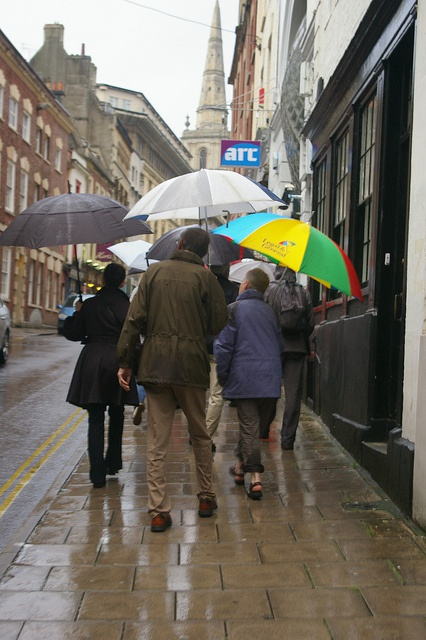Describe the objects in this image and their specific colors. I can see people in white, black, maroon, and gray tones, people in white, black, and gray tones, people in white, black, and gray tones, umbrella in white, lightgray, darkgray, and gray tones, and umbrella in white, gold, green, and lightblue tones in this image. 